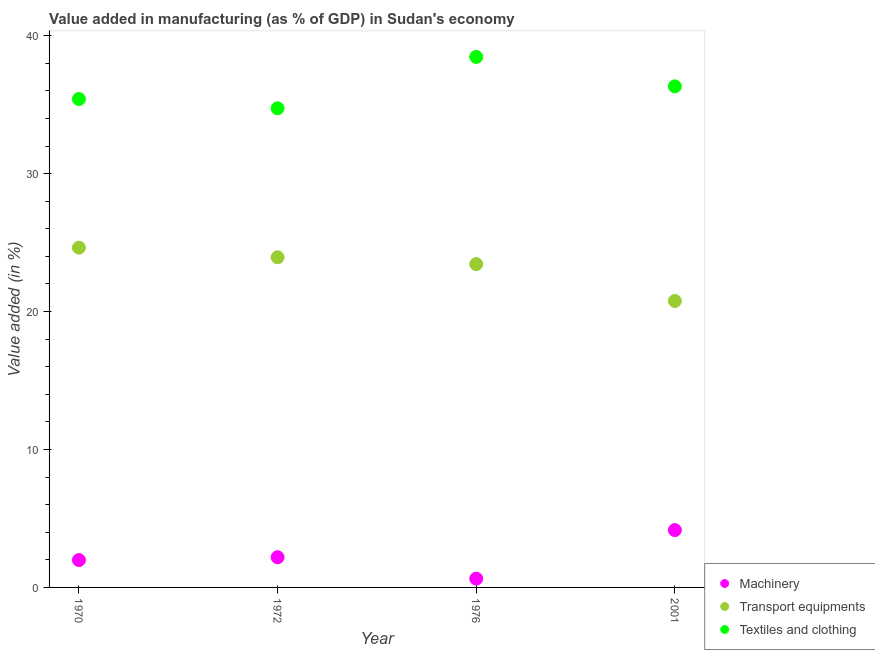What is the value added in manufacturing transport equipments in 2001?
Ensure brevity in your answer.  20.77. Across all years, what is the maximum value added in manufacturing transport equipments?
Your answer should be very brief. 24.63. Across all years, what is the minimum value added in manufacturing transport equipments?
Keep it short and to the point. 20.77. In which year was the value added in manufacturing textile and clothing maximum?
Your answer should be compact. 1976. In which year was the value added in manufacturing transport equipments minimum?
Your answer should be very brief. 2001. What is the total value added in manufacturing textile and clothing in the graph?
Provide a short and direct response. 144.93. What is the difference between the value added in manufacturing machinery in 1972 and that in 2001?
Your response must be concise. -1.97. What is the difference between the value added in manufacturing machinery in 1972 and the value added in manufacturing textile and clothing in 1970?
Your response must be concise. -33.22. What is the average value added in manufacturing transport equipments per year?
Offer a very short reply. 23.19. In the year 1972, what is the difference between the value added in manufacturing textile and clothing and value added in manufacturing machinery?
Offer a terse response. 32.55. What is the ratio of the value added in manufacturing textile and clothing in 1976 to that in 2001?
Keep it short and to the point. 1.06. Is the difference between the value added in manufacturing transport equipments in 1970 and 1976 greater than the difference between the value added in manufacturing machinery in 1970 and 1976?
Offer a terse response. No. What is the difference between the highest and the second highest value added in manufacturing machinery?
Give a very brief answer. 1.97. What is the difference between the highest and the lowest value added in manufacturing transport equipments?
Your response must be concise. 3.86. Is the sum of the value added in manufacturing machinery in 1970 and 1976 greater than the maximum value added in manufacturing transport equipments across all years?
Give a very brief answer. No. How many years are there in the graph?
Ensure brevity in your answer.  4. What is the difference between two consecutive major ticks on the Y-axis?
Your answer should be very brief. 10. Does the graph contain any zero values?
Your answer should be very brief. No. How many legend labels are there?
Your response must be concise. 3. What is the title of the graph?
Offer a terse response. Value added in manufacturing (as % of GDP) in Sudan's economy. What is the label or title of the X-axis?
Keep it short and to the point. Year. What is the label or title of the Y-axis?
Make the answer very short. Value added (in %). What is the Value added (in %) of Machinery in 1970?
Your answer should be very brief. 1.98. What is the Value added (in %) of Transport equipments in 1970?
Provide a succinct answer. 24.63. What is the Value added (in %) of Textiles and clothing in 1970?
Your answer should be very brief. 35.41. What is the Value added (in %) of Machinery in 1972?
Give a very brief answer. 2.19. What is the Value added (in %) of Transport equipments in 1972?
Offer a terse response. 23.93. What is the Value added (in %) of Textiles and clothing in 1972?
Offer a terse response. 34.73. What is the Value added (in %) of Machinery in 1976?
Your answer should be very brief. 0.64. What is the Value added (in %) in Transport equipments in 1976?
Your answer should be compact. 23.44. What is the Value added (in %) of Textiles and clothing in 1976?
Make the answer very short. 38.46. What is the Value added (in %) of Machinery in 2001?
Offer a very short reply. 4.16. What is the Value added (in %) of Transport equipments in 2001?
Give a very brief answer. 20.77. What is the Value added (in %) of Textiles and clothing in 2001?
Keep it short and to the point. 36.32. Across all years, what is the maximum Value added (in %) of Machinery?
Your answer should be compact. 4.16. Across all years, what is the maximum Value added (in %) of Transport equipments?
Make the answer very short. 24.63. Across all years, what is the maximum Value added (in %) in Textiles and clothing?
Your answer should be very brief. 38.46. Across all years, what is the minimum Value added (in %) of Machinery?
Your answer should be very brief. 0.64. Across all years, what is the minimum Value added (in %) in Transport equipments?
Keep it short and to the point. 20.77. Across all years, what is the minimum Value added (in %) of Textiles and clothing?
Your response must be concise. 34.73. What is the total Value added (in %) of Machinery in the graph?
Make the answer very short. 8.97. What is the total Value added (in %) in Transport equipments in the graph?
Make the answer very short. 92.77. What is the total Value added (in %) of Textiles and clothing in the graph?
Offer a terse response. 144.93. What is the difference between the Value added (in %) of Machinery in 1970 and that in 1972?
Offer a terse response. -0.21. What is the difference between the Value added (in %) in Transport equipments in 1970 and that in 1972?
Offer a terse response. 0.7. What is the difference between the Value added (in %) in Textiles and clothing in 1970 and that in 1972?
Your answer should be compact. 0.67. What is the difference between the Value added (in %) of Machinery in 1970 and that in 1976?
Offer a very short reply. 1.35. What is the difference between the Value added (in %) of Transport equipments in 1970 and that in 1976?
Your answer should be very brief. 1.19. What is the difference between the Value added (in %) in Textiles and clothing in 1970 and that in 1976?
Your answer should be compact. -3.05. What is the difference between the Value added (in %) of Machinery in 1970 and that in 2001?
Your response must be concise. -2.17. What is the difference between the Value added (in %) of Transport equipments in 1970 and that in 2001?
Your response must be concise. 3.86. What is the difference between the Value added (in %) in Textiles and clothing in 1970 and that in 2001?
Offer a very short reply. -0.92. What is the difference between the Value added (in %) of Machinery in 1972 and that in 1976?
Provide a succinct answer. 1.55. What is the difference between the Value added (in %) of Transport equipments in 1972 and that in 1976?
Your response must be concise. 0.49. What is the difference between the Value added (in %) in Textiles and clothing in 1972 and that in 1976?
Provide a succinct answer. -3.72. What is the difference between the Value added (in %) of Machinery in 1972 and that in 2001?
Offer a very short reply. -1.97. What is the difference between the Value added (in %) in Transport equipments in 1972 and that in 2001?
Offer a terse response. 3.17. What is the difference between the Value added (in %) in Textiles and clothing in 1972 and that in 2001?
Your answer should be very brief. -1.59. What is the difference between the Value added (in %) of Machinery in 1976 and that in 2001?
Offer a terse response. -3.52. What is the difference between the Value added (in %) in Transport equipments in 1976 and that in 2001?
Your answer should be very brief. 2.67. What is the difference between the Value added (in %) in Textiles and clothing in 1976 and that in 2001?
Offer a very short reply. 2.14. What is the difference between the Value added (in %) in Machinery in 1970 and the Value added (in %) in Transport equipments in 1972?
Ensure brevity in your answer.  -21.95. What is the difference between the Value added (in %) in Machinery in 1970 and the Value added (in %) in Textiles and clothing in 1972?
Ensure brevity in your answer.  -32.75. What is the difference between the Value added (in %) of Transport equipments in 1970 and the Value added (in %) of Textiles and clothing in 1972?
Give a very brief answer. -10.1. What is the difference between the Value added (in %) of Machinery in 1970 and the Value added (in %) of Transport equipments in 1976?
Give a very brief answer. -21.46. What is the difference between the Value added (in %) in Machinery in 1970 and the Value added (in %) in Textiles and clothing in 1976?
Your answer should be very brief. -36.48. What is the difference between the Value added (in %) of Transport equipments in 1970 and the Value added (in %) of Textiles and clothing in 1976?
Ensure brevity in your answer.  -13.83. What is the difference between the Value added (in %) in Machinery in 1970 and the Value added (in %) in Transport equipments in 2001?
Offer a terse response. -18.78. What is the difference between the Value added (in %) of Machinery in 1970 and the Value added (in %) of Textiles and clothing in 2001?
Make the answer very short. -34.34. What is the difference between the Value added (in %) of Transport equipments in 1970 and the Value added (in %) of Textiles and clothing in 2001?
Your answer should be very brief. -11.69. What is the difference between the Value added (in %) of Machinery in 1972 and the Value added (in %) of Transport equipments in 1976?
Ensure brevity in your answer.  -21.25. What is the difference between the Value added (in %) of Machinery in 1972 and the Value added (in %) of Textiles and clothing in 1976?
Provide a succinct answer. -36.27. What is the difference between the Value added (in %) of Transport equipments in 1972 and the Value added (in %) of Textiles and clothing in 1976?
Ensure brevity in your answer.  -14.53. What is the difference between the Value added (in %) of Machinery in 1972 and the Value added (in %) of Transport equipments in 2001?
Offer a very short reply. -18.58. What is the difference between the Value added (in %) of Machinery in 1972 and the Value added (in %) of Textiles and clothing in 2001?
Offer a very short reply. -34.14. What is the difference between the Value added (in %) of Transport equipments in 1972 and the Value added (in %) of Textiles and clothing in 2001?
Give a very brief answer. -12.39. What is the difference between the Value added (in %) of Machinery in 1976 and the Value added (in %) of Transport equipments in 2001?
Offer a very short reply. -20.13. What is the difference between the Value added (in %) in Machinery in 1976 and the Value added (in %) in Textiles and clothing in 2001?
Offer a terse response. -35.69. What is the difference between the Value added (in %) in Transport equipments in 1976 and the Value added (in %) in Textiles and clothing in 2001?
Your answer should be very brief. -12.89. What is the average Value added (in %) of Machinery per year?
Your response must be concise. 2.24. What is the average Value added (in %) in Transport equipments per year?
Offer a very short reply. 23.19. What is the average Value added (in %) in Textiles and clothing per year?
Make the answer very short. 36.23. In the year 1970, what is the difference between the Value added (in %) in Machinery and Value added (in %) in Transport equipments?
Your answer should be compact. -22.65. In the year 1970, what is the difference between the Value added (in %) in Machinery and Value added (in %) in Textiles and clothing?
Keep it short and to the point. -33.43. In the year 1970, what is the difference between the Value added (in %) in Transport equipments and Value added (in %) in Textiles and clothing?
Your answer should be very brief. -10.78. In the year 1972, what is the difference between the Value added (in %) in Machinery and Value added (in %) in Transport equipments?
Make the answer very short. -21.75. In the year 1972, what is the difference between the Value added (in %) of Machinery and Value added (in %) of Textiles and clothing?
Your answer should be compact. -32.55. In the year 1972, what is the difference between the Value added (in %) in Transport equipments and Value added (in %) in Textiles and clothing?
Keep it short and to the point. -10.8. In the year 1976, what is the difference between the Value added (in %) in Machinery and Value added (in %) in Transport equipments?
Ensure brevity in your answer.  -22.8. In the year 1976, what is the difference between the Value added (in %) of Machinery and Value added (in %) of Textiles and clothing?
Your answer should be very brief. -37.82. In the year 1976, what is the difference between the Value added (in %) of Transport equipments and Value added (in %) of Textiles and clothing?
Ensure brevity in your answer.  -15.02. In the year 2001, what is the difference between the Value added (in %) in Machinery and Value added (in %) in Transport equipments?
Offer a terse response. -16.61. In the year 2001, what is the difference between the Value added (in %) in Machinery and Value added (in %) in Textiles and clothing?
Provide a short and direct response. -32.17. In the year 2001, what is the difference between the Value added (in %) in Transport equipments and Value added (in %) in Textiles and clothing?
Give a very brief answer. -15.56. What is the ratio of the Value added (in %) of Machinery in 1970 to that in 1972?
Your response must be concise. 0.91. What is the ratio of the Value added (in %) of Transport equipments in 1970 to that in 1972?
Make the answer very short. 1.03. What is the ratio of the Value added (in %) in Textiles and clothing in 1970 to that in 1972?
Offer a very short reply. 1.02. What is the ratio of the Value added (in %) of Machinery in 1970 to that in 1976?
Keep it short and to the point. 3.11. What is the ratio of the Value added (in %) in Transport equipments in 1970 to that in 1976?
Ensure brevity in your answer.  1.05. What is the ratio of the Value added (in %) in Textiles and clothing in 1970 to that in 1976?
Offer a very short reply. 0.92. What is the ratio of the Value added (in %) of Machinery in 1970 to that in 2001?
Your answer should be very brief. 0.48. What is the ratio of the Value added (in %) of Transport equipments in 1970 to that in 2001?
Offer a very short reply. 1.19. What is the ratio of the Value added (in %) of Textiles and clothing in 1970 to that in 2001?
Make the answer very short. 0.97. What is the ratio of the Value added (in %) of Machinery in 1972 to that in 1976?
Your response must be concise. 3.43. What is the ratio of the Value added (in %) in Transport equipments in 1972 to that in 1976?
Give a very brief answer. 1.02. What is the ratio of the Value added (in %) in Textiles and clothing in 1972 to that in 1976?
Your response must be concise. 0.9. What is the ratio of the Value added (in %) of Machinery in 1972 to that in 2001?
Your answer should be very brief. 0.53. What is the ratio of the Value added (in %) of Transport equipments in 1972 to that in 2001?
Provide a short and direct response. 1.15. What is the ratio of the Value added (in %) of Textiles and clothing in 1972 to that in 2001?
Your answer should be very brief. 0.96. What is the ratio of the Value added (in %) in Machinery in 1976 to that in 2001?
Give a very brief answer. 0.15. What is the ratio of the Value added (in %) in Transport equipments in 1976 to that in 2001?
Provide a short and direct response. 1.13. What is the ratio of the Value added (in %) in Textiles and clothing in 1976 to that in 2001?
Offer a very short reply. 1.06. What is the difference between the highest and the second highest Value added (in %) in Machinery?
Provide a succinct answer. 1.97. What is the difference between the highest and the second highest Value added (in %) of Transport equipments?
Keep it short and to the point. 0.7. What is the difference between the highest and the second highest Value added (in %) of Textiles and clothing?
Your answer should be very brief. 2.14. What is the difference between the highest and the lowest Value added (in %) of Machinery?
Offer a terse response. 3.52. What is the difference between the highest and the lowest Value added (in %) of Transport equipments?
Offer a very short reply. 3.86. What is the difference between the highest and the lowest Value added (in %) in Textiles and clothing?
Make the answer very short. 3.72. 